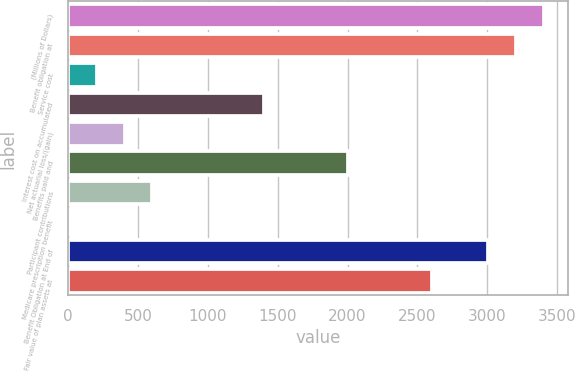Convert chart. <chart><loc_0><loc_0><loc_500><loc_500><bar_chart><fcel>(Millions of Dollars)<fcel>Benefit obligation at<fcel>Service cost<fcel>Interest cost on accumulated<fcel>Net actuarial loss/(gain)<fcel>Benefits paid and<fcel>Participant contributions<fcel>Medicare prescription benefit<fcel>Benefit Obligation at End of<fcel>Fair value of plan assets at<nl><fcel>3407.4<fcel>3207.2<fcel>204.2<fcel>1405.4<fcel>404.4<fcel>2006<fcel>604.6<fcel>4<fcel>3007<fcel>2606.6<nl></chart> 